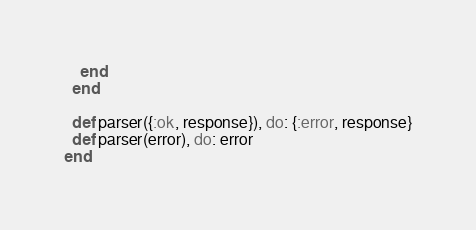<code> <loc_0><loc_0><loc_500><loc_500><_Elixir_>    end
  end

  def parser({:ok, response}), do: {:error, response}
  def parser(error), do: error
end
</code> 